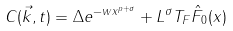Convert formula to latex. <formula><loc_0><loc_0><loc_500><loc_500>C ( \vec { k } , t ) = \Delta e ^ { - w x ^ { p + \sigma } } + L ^ { \sigma } T _ { F } \hat { F } _ { 0 } ( x )</formula> 